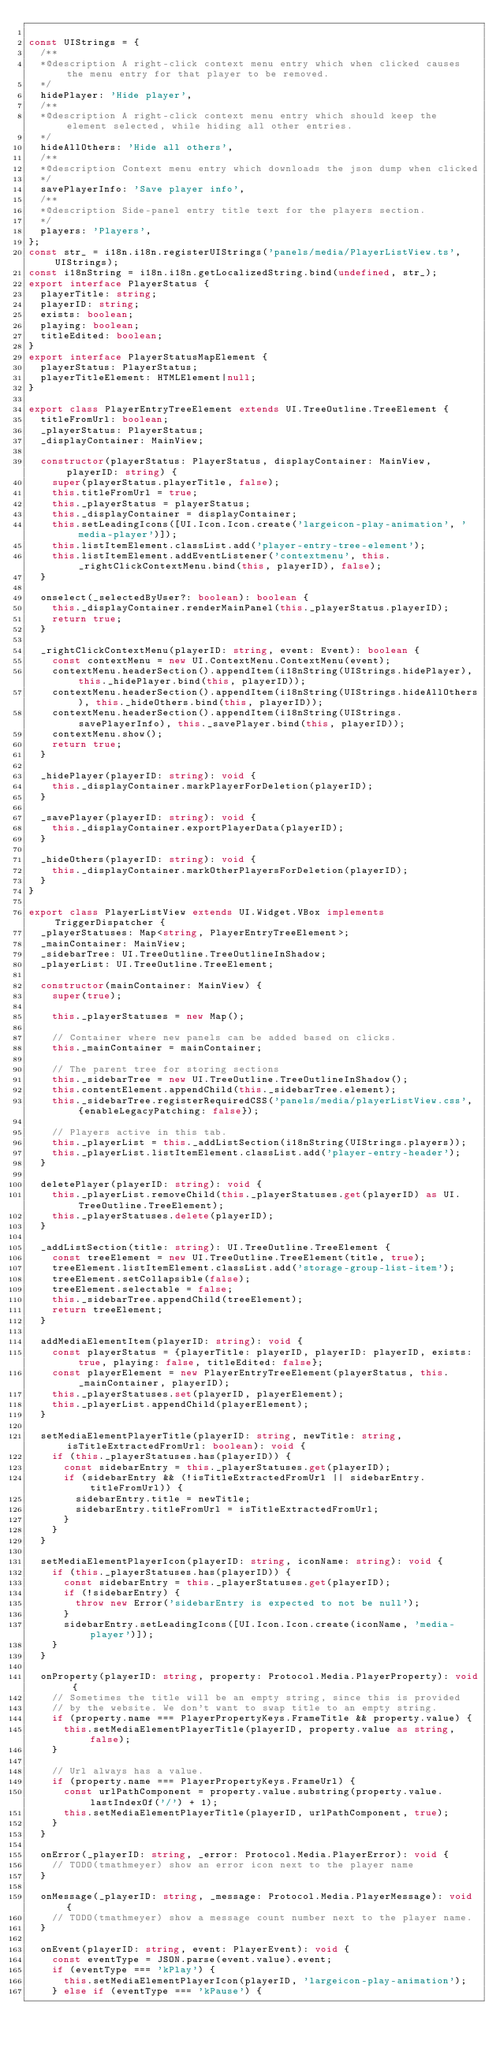Convert code to text. <code><loc_0><loc_0><loc_500><loc_500><_TypeScript_>
const UIStrings = {
  /**
  *@description A right-click context menu entry which when clicked causes the menu entry for that player to be removed.
  */
  hidePlayer: 'Hide player',
  /**
  *@description A right-click context menu entry which should keep the element selected, while hiding all other entries.
  */
  hideAllOthers: 'Hide all others',
  /**
  *@description Context menu entry which downloads the json dump when clicked
  */
  savePlayerInfo: 'Save player info',
  /**
  *@description Side-panel entry title text for the players section.
  */
  players: 'Players',
};
const str_ = i18n.i18n.registerUIStrings('panels/media/PlayerListView.ts', UIStrings);
const i18nString = i18n.i18n.getLocalizedString.bind(undefined, str_);
export interface PlayerStatus {
  playerTitle: string;
  playerID: string;
  exists: boolean;
  playing: boolean;
  titleEdited: boolean;
}
export interface PlayerStatusMapElement {
  playerStatus: PlayerStatus;
  playerTitleElement: HTMLElement|null;
}

export class PlayerEntryTreeElement extends UI.TreeOutline.TreeElement {
  titleFromUrl: boolean;
  _playerStatus: PlayerStatus;
  _displayContainer: MainView;

  constructor(playerStatus: PlayerStatus, displayContainer: MainView, playerID: string) {
    super(playerStatus.playerTitle, false);
    this.titleFromUrl = true;
    this._playerStatus = playerStatus;
    this._displayContainer = displayContainer;
    this.setLeadingIcons([UI.Icon.Icon.create('largeicon-play-animation', 'media-player')]);
    this.listItemElement.classList.add('player-entry-tree-element');
    this.listItemElement.addEventListener('contextmenu', this._rightClickContextMenu.bind(this, playerID), false);
  }

  onselect(_selectedByUser?: boolean): boolean {
    this._displayContainer.renderMainPanel(this._playerStatus.playerID);
    return true;
  }

  _rightClickContextMenu(playerID: string, event: Event): boolean {
    const contextMenu = new UI.ContextMenu.ContextMenu(event);
    contextMenu.headerSection().appendItem(i18nString(UIStrings.hidePlayer), this._hidePlayer.bind(this, playerID));
    contextMenu.headerSection().appendItem(i18nString(UIStrings.hideAllOthers), this._hideOthers.bind(this, playerID));
    contextMenu.headerSection().appendItem(i18nString(UIStrings.savePlayerInfo), this._savePlayer.bind(this, playerID));
    contextMenu.show();
    return true;
  }

  _hidePlayer(playerID: string): void {
    this._displayContainer.markPlayerForDeletion(playerID);
  }

  _savePlayer(playerID: string): void {
    this._displayContainer.exportPlayerData(playerID);
  }

  _hideOthers(playerID: string): void {
    this._displayContainer.markOtherPlayersForDeletion(playerID);
  }
}

export class PlayerListView extends UI.Widget.VBox implements TriggerDispatcher {
  _playerStatuses: Map<string, PlayerEntryTreeElement>;
  _mainContainer: MainView;
  _sidebarTree: UI.TreeOutline.TreeOutlineInShadow;
  _playerList: UI.TreeOutline.TreeElement;

  constructor(mainContainer: MainView) {
    super(true);

    this._playerStatuses = new Map();

    // Container where new panels can be added based on clicks.
    this._mainContainer = mainContainer;

    // The parent tree for storing sections
    this._sidebarTree = new UI.TreeOutline.TreeOutlineInShadow();
    this.contentElement.appendChild(this._sidebarTree.element);
    this._sidebarTree.registerRequiredCSS('panels/media/playerListView.css', {enableLegacyPatching: false});

    // Players active in this tab.
    this._playerList = this._addListSection(i18nString(UIStrings.players));
    this._playerList.listItemElement.classList.add('player-entry-header');
  }

  deletePlayer(playerID: string): void {
    this._playerList.removeChild(this._playerStatuses.get(playerID) as UI.TreeOutline.TreeElement);
    this._playerStatuses.delete(playerID);
  }

  _addListSection(title: string): UI.TreeOutline.TreeElement {
    const treeElement = new UI.TreeOutline.TreeElement(title, true);
    treeElement.listItemElement.classList.add('storage-group-list-item');
    treeElement.setCollapsible(false);
    treeElement.selectable = false;
    this._sidebarTree.appendChild(treeElement);
    return treeElement;
  }

  addMediaElementItem(playerID: string): void {
    const playerStatus = {playerTitle: playerID, playerID: playerID, exists: true, playing: false, titleEdited: false};
    const playerElement = new PlayerEntryTreeElement(playerStatus, this._mainContainer, playerID);
    this._playerStatuses.set(playerID, playerElement);
    this._playerList.appendChild(playerElement);
  }

  setMediaElementPlayerTitle(playerID: string, newTitle: string, isTitleExtractedFromUrl: boolean): void {
    if (this._playerStatuses.has(playerID)) {
      const sidebarEntry = this._playerStatuses.get(playerID);
      if (sidebarEntry && (!isTitleExtractedFromUrl || sidebarEntry.titleFromUrl)) {
        sidebarEntry.title = newTitle;
        sidebarEntry.titleFromUrl = isTitleExtractedFromUrl;
      }
    }
  }

  setMediaElementPlayerIcon(playerID: string, iconName: string): void {
    if (this._playerStatuses.has(playerID)) {
      const sidebarEntry = this._playerStatuses.get(playerID);
      if (!sidebarEntry) {
        throw new Error('sidebarEntry is expected to not be null');
      }
      sidebarEntry.setLeadingIcons([UI.Icon.Icon.create(iconName, 'media-player')]);
    }
  }

  onProperty(playerID: string, property: Protocol.Media.PlayerProperty): void {
    // Sometimes the title will be an empty string, since this is provided
    // by the website. We don't want to swap title to an empty string.
    if (property.name === PlayerPropertyKeys.FrameTitle && property.value) {
      this.setMediaElementPlayerTitle(playerID, property.value as string, false);
    }

    // Url always has a value.
    if (property.name === PlayerPropertyKeys.FrameUrl) {
      const urlPathComponent = property.value.substring(property.value.lastIndexOf('/') + 1);
      this.setMediaElementPlayerTitle(playerID, urlPathComponent, true);
    }
  }

  onError(_playerID: string, _error: Protocol.Media.PlayerError): void {
    // TODO(tmathmeyer) show an error icon next to the player name
  }

  onMessage(_playerID: string, _message: Protocol.Media.PlayerMessage): void {
    // TODO(tmathmeyer) show a message count number next to the player name.
  }

  onEvent(playerID: string, event: PlayerEvent): void {
    const eventType = JSON.parse(event.value).event;
    if (eventType === 'kPlay') {
      this.setMediaElementPlayerIcon(playerID, 'largeicon-play-animation');
    } else if (eventType === 'kPause') {</code> 